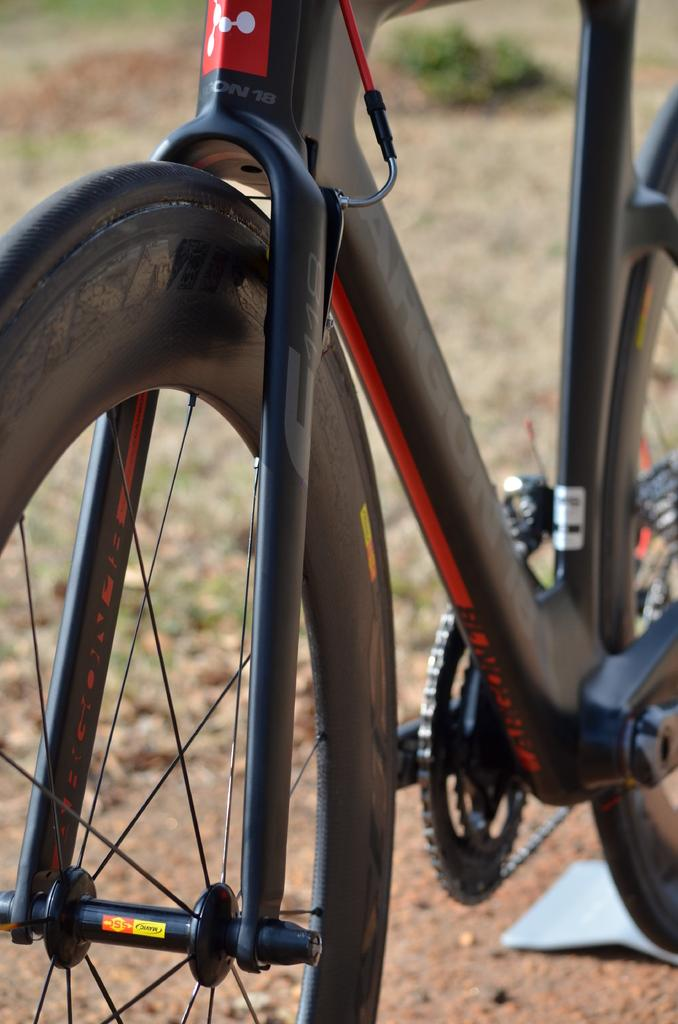What is the main object in the image? There is a bicycle in the image. Where is the bicycle located? The bicycle is on the surface. Can you describe the background of the image? The background of the image is blurred. What type of seat can be seen on the bicycle in the image? There is no seat visible on the bicycle in the image. How long is the journey depicted in the image? The image does not depict a journey, as it only shows a bicycle on a surface with a blurred background. 